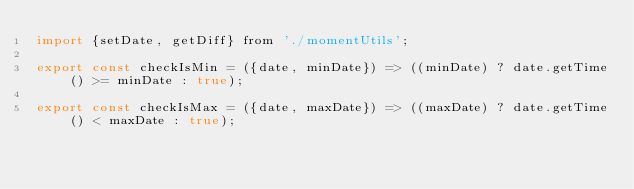<code> <loc_0><loc_0><loc_500><loc_500><_JavaScript_>import {setDate, getDiff} from './momentUtils';

export const checkIsMin = ({date, minDate}) => ((minDate) ? date.getTime() >= minDate : true);

export const checkIsMax = ({date, maxDate}) => ((maxDate) ? date.getTime() < maxDate : true);
</code> 